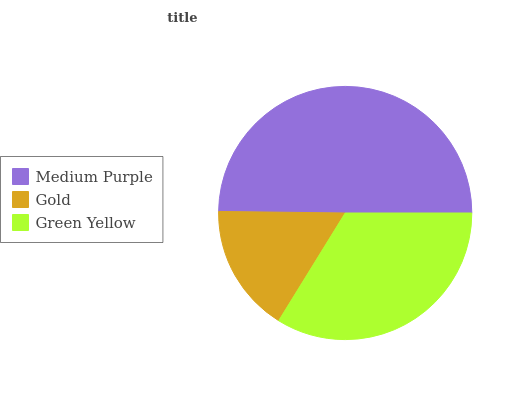Is Gold the minimum?
Answer yes or no. Yes. Is Medium Purple the maximum?
Answer yes or no. Yes. Is Green Yellow the minimum?
Answer yes or no. No. Is Green Yellow the maximum?
Answer yes or no. No. Is Green Yellow greater than Gold?
Answer yes or no. Yes. Is Gold less than Green Yellow?
Answer yes or no. Yes. Is Gold greater than Green Yellow?
Answer yes or no. No. Is Green Yellow less than Gold?
Answer yes or no. No. Is Green Yellow the high median?
Answer yes or no. Yes. Is Green Yellow the low median?
Answer yes or no. Yes. Is Medium Purple the high median?
Answer yes or no. No. Is Medium Purple the low median?
Answer yes or no. No. 